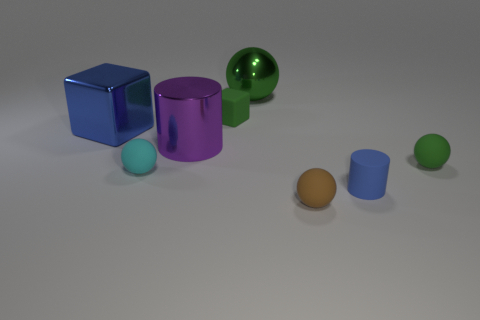There is a ball that is the same size as the blue metal block; what material is it?
Your response must be concise. Metal. Do the blue object left of the big green metallic sphere and the purple metallic object have the same shape?
Make the answer very short. No. Do the big shiny sphere and the metallic block have the same color?
Ensure brevity in your answer.  No. How many things are either small rubber things on the right side of the tiny blue thing or small objects?
Give a very brief answer. 5. What shape is the purple metal object that is the same size as the green metal ball?
Keep it short and to the point. Cylinder. Is the size of the ball left of the green block the same as the blue thing to the left of the green metal sphere?
Give a very brief answer. No. There is a cube that is made of the same material as the brown sphere; what is its color?
Keep it short and to the point. Green. Are the object that is on the right side of the small blue cylinder and the cube that is to the left of the big purple cylinder made of the same material?
Provide a short and direct response. No. Are there any purple cylinders that have the same size as the brown rubber object?
Provide a succinct answer. No. There is a sphere that is behind the small sphere that is on the right side of the brown sphere; how big is it?
Your answer should be very brief. Large. 